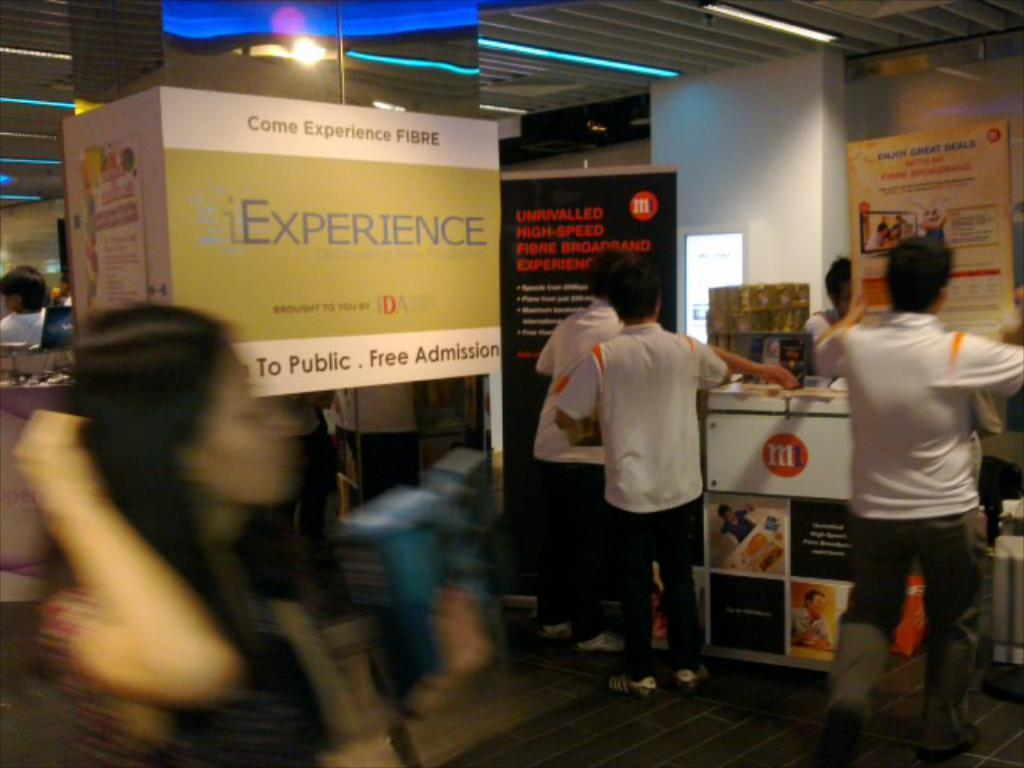What is the overall quality of the image? The image is blurry. Can you identify any subjects in the image? Yes, there are people in the image. What else can be seen in the image besides people? There are banners and lights on the roof in the image. What type of nose can be seen on the person in the image? There is no specific nose visible in the image, as it is blurry and does not allow for the identification of facial features. 